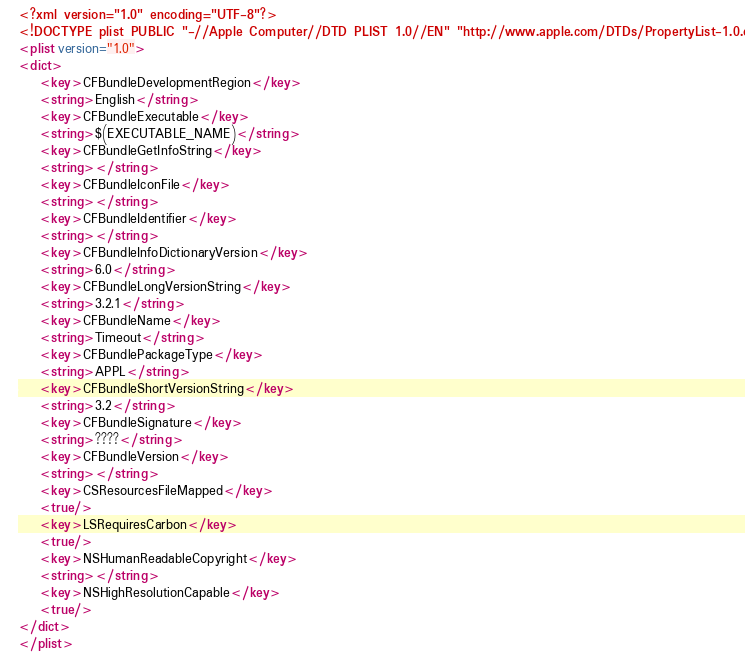<code> <loc_0><loc_0><loc_500><loc_500><_XML_><?xml version="1.0" encoding="UTF-8"?>
<!DOCTYPE plist PUBLIC "-//Apple Computer//DTD PLIST 1.0//EN" "http://www.apple.com/DTDs/PropertyList-1.0.dtd">
<plist version="1.0">
<dict>
	<key>CFBundleDevelopmentRegion</key>
	<string>English</string>
	<key>CFBundleExecutable</key>
	<string>$(EXECUTABLE_NAME)</string>
	<key>CFBundleGetInfoString</key>
	<string></string>
	<key>CFBundleIconFile</key>
	<string></string>
	<key>CFBundleIdentifier</key>
	<string></string>
	<key>CFBundleInfoDictionaryVersion</key>
	<string>6.0</string>
	<key>CFBundleLongVersionString</key>
	<string>3.2.1</string>
	<key>CFBundleName</key>
	<string>Timeout</string>
	<key>CFBundlePackageType</key>
	<string>APPL</string>
	<key>CFBundleShortVersionString</key>
	<string>3.2</string>
	<key>CFBundleSignature</key>
	<string>????</string>
	<key>CFBundleVersion</key>
	<string></string>
	<key>CSResourcesFileMapped</key>
	<true/>
	<key>LSRequiresCarbon</key>
	<true/>
	<key>NSHumanReadableCopyright</key>
	<string></string>
	<key>NSHighResolutionCapable</key>
	<true/>
</dict>
</plist>
</code> 